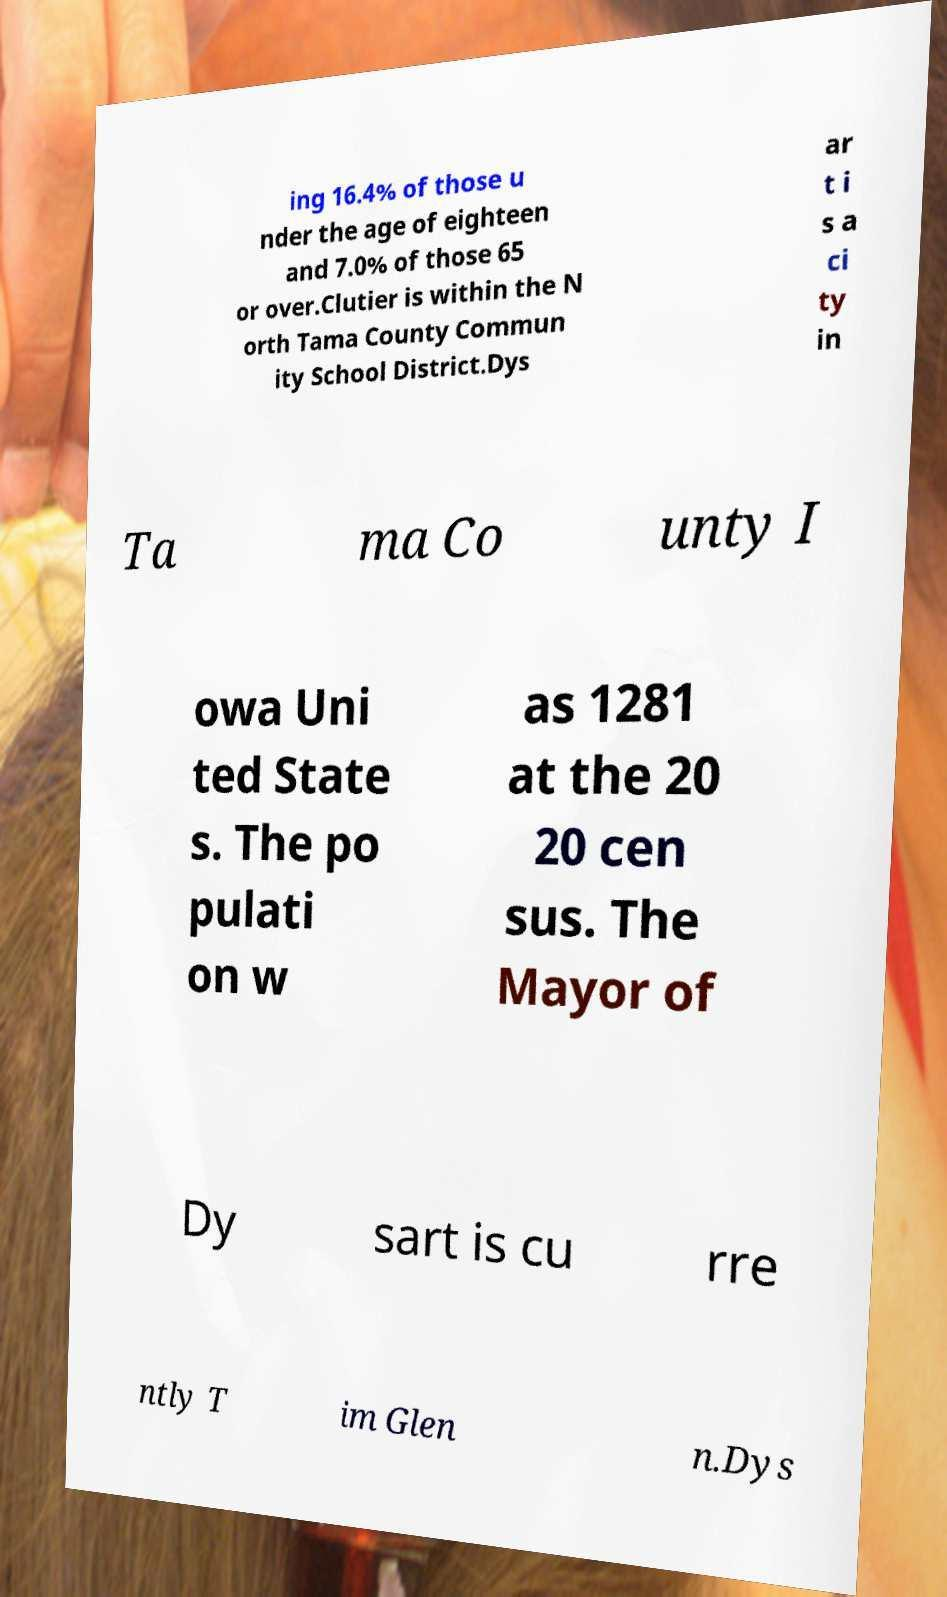There's text embedded in this image that I need extracted. Can you transcribe it verbatim? ing 16.4% of those u nder the age of eighteen and 7.0% of those 65 or over.Clutier is within the N orth Tama County Commun ity School District.Dys ar t i s a ci ty in Ta ma Co unty I owa Uni ted State s. The po pulati on w as 1281 at the 20 20 cen sus. The Mayor of Dy sart is cu rre ntly T im Glen n.Dys 